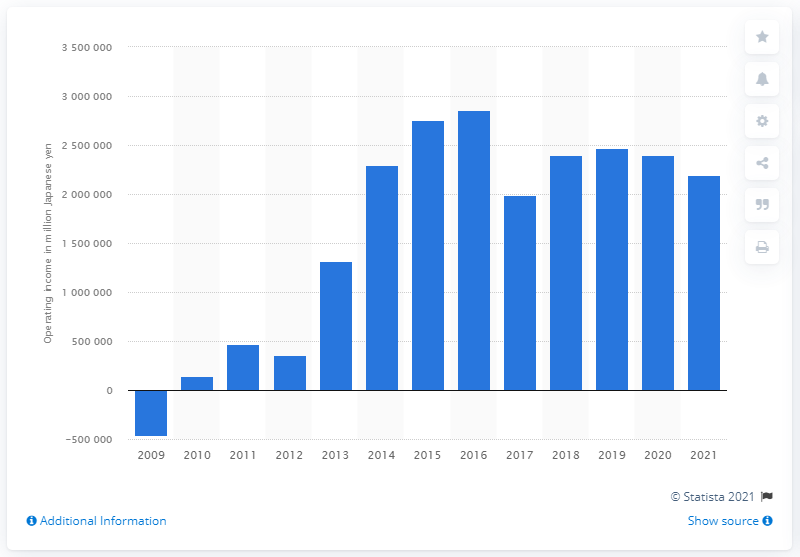Outline some significant characteristics in this image. In 2021, Toyota's operating income was 219,774,800. 